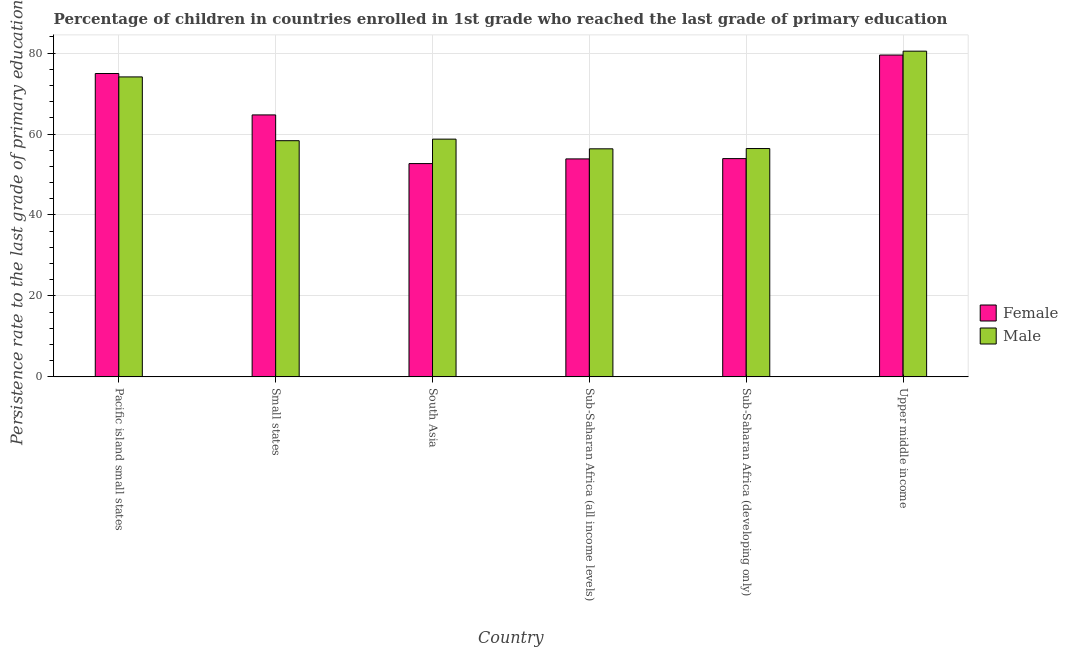What is the label of the 4th group of bars from the left?
Make the answer very short. Sub-Saharan Africa (all income levels). In how many cases, is the number of bars for a given country not equal to the number of legend labels?
Your answer should be very brief. 0. What is the persistence rate of male students in Sub-Saharan Africa (developing only)?
Offer a terse response. 56.41. Across all countries, what is the maximum persistence rate of male students?
Your response must be concise. 80.47. Across all countries, what is the minimum persistence rate of female students?
Offer a very short reply. 52.7. In which country was the persistence rate of female students maximum?
Your response must be concise. Upper middle income. In which country was the persistence rate of female students minimum?
Provide a succinct answer. South Asia. What is the total persistence rate of male students in the graph?
Offer a terse response. 384.43. What is the difference between the persistence rate of female students in Small states and that in Sub-Saharan Africa (all income levels)?
Offer a very short reply. 10.87. What is the difference between the persistence rate of female students in Sub-Saharan Africa (all income levels) and the persistence rate of male students in Pacific island small states?
Keep it short and to the point. -20.26. What is the average persistence rate of male students per country?
Offer a very short reply. 64.07. What is the difference between the persistence rate of female students and persistence rate of male students in Upper middle income?
Give a very brief answer. -0.96. What is the ratio of the persistence rate of male students in South Asia to that in Upper middle income?
Provide a short and direct response. 0.73. Is the persistence rate of male students in Small states less than that in South Asia?
Make the answer very short. Yes. Is the difference between the persistence rate of female students in Small states and South Asia greater than the difference between the persistence rate of male students in Small states and South Asia?
Make the answer very short. Yes. What is the difference between the highest and the second highest persistence rate of female students?
Make the answer very short. 4.57. What is the difference between the highest and the lowest persistence rate of female students?
Your response must be concise. 26.82. What does the 2nd bar from the left in South Asia represents?
Provide a short and direct response. Male. How many countries are there in the graph?
Offer a very short reply. 6. Does the graph contain any zero values?
Your answer should be very brief. No. Does the graph contain grids?
Your response must be concise. Yes. Where does the legend appear in the graph?
Your response must be concise. Center right. What is the title of the graph?
Ensure brevity in your answer.  Percentage of children in countries enrolled in 1st grade who reached the last grade of primary education. Does "IMF nonconcessional" appear as one of the legend labels in the graph?
Provide a succinct answer. No. What is the label or title of the X-axis?
Offer a very short reply. Country. What is the label or title of the Y-axis?
Give a very brief answer. Persistence rate to the last grade of primary education (%). What is the Persistence rate to the last grade of primary education (%) in Female in Pacific island small states?
Provide a succinct answer. 74.95. What is the Persistence rate to the last grade of primary education (%) in Male in Pacific island small states?
Provide a short and direct response. 74.11. What is the Persistence rate to the last grade of primary education (%) of Female in Small states?
Make the answer very short. 64.72. What is the Persistence rate to the last grade of primary education (%) in Male in Small states?
Make the answer very short. 58.35. What is the Persistence rate to the last grade of primary education (%) in Female in South Asia?
Provide a succinct answer. 52.7. What is the Persistence rate to the last grade of primary education (%) of Male in South Asia?
Provide a succinct answer. 58.74. What is the Persistence rate to the last grade of primary education (%) of Female in Sub-Saharan Africa (all income levels)?
Your response must be concise. 53.85. What is the Persistence rate to the last grade of primary education (%) of Male in Sub-Saharan Africa (all income levels)?
Provide a short and direct response. 56.34. What is the Persistence rate to the last grade of primary education (%) in Female in Sub-Saharan Africa (developing only)?
Give a very brief answer. 53.93. What is the Persistence rate to the last grade of primary education (%) in Male in Sub-Saharan Africa (developing only)?
Provide a short and direct response. 56.41. What is the Persistence rate to the last grade of primary education (%) of Female in Upper middle income?
Offer a terse response. 79.52. What is the Persistence rate to the last grade of primary education (%) in Male in Upper middle income?
Your answer should be compact. 80.47. Across all countries, what is the maximum Persistence rate to the last grade of primary education (%) of Female?
Provide a short and direct response. 79.52. Across all countries, what is the maximum Persistence rate to the last grade of primary education (%) of Male?
Your response must be concise. 80.47. Across all countries, what is the minimum Persistence rate to the last grade of primary education (%) of Female?
Make the answer very short. 52.7. Across all countries, what is the minimum Persistence rate to the last grade of primary education (%) in Male?
Your answer should be very brief. 56.34. What is the total Persistence rate to the last grade of primary education (%) of Female in the graph?
Keep it short and to the point. 379.67. What is the total Persistence rate to the last grade of primary education (%) of Male in the graph?
Your answer should be compact. 384.43. What is the difference between the Persistence rate to the last grade of primary education (%) of Female in Pacific island small states and that in Small states?
Provide a short and direct response. 10.23. What is the difference between the Persistence rate to the last grade of primary education (%) of Male in Pacific island small states and that in Small states?
Provide a short and direct response. 15.76. What is the difference between the Persistence rate to the last grade of primary education (%) in Female in Pacific island small states and that in South Asia?
Keep it short and to the point. 22.25. What is the difference between the Persistence rate to the last grade of primary education (%) in Male in Pacific island small states and that in South Asia?
Keep it short and to the point. 15.37. What is the difference between the Persistence rate to the last grade of primary education (%) of Female in Pacific island small states and that in Sub-Saharan Africa (all income levels)?
Provide a succinct answer. 21.09. What is the difference between the Persistence rate to the last grade of primary education (%) of Male in Pacific island small states and that in Sub-Saharan Africa (all income levels)?
Offer a terse response. 17.77. What is the difference between the Persistence rate to the last grade of primary education (%) of Female in Pacific island small states and that in Sub-Saharan Africa (developing only)?
Offer a very short reply. 21.02. What is the difference between the Persistence rate to the last grade of primary education (%) of Male in Pacific island small states and that in Sub-Saharan Africa (developing only)?
Keep it short and to the point. 17.7. What is the difference between the Persistence rate to the last grade of primary education (%) in Female in Pacific island small states and that in Upper middle income?
Your answer should be very brief. -4.57. What is the difference between the Persistence rate to the last grade of primary education (%) of Male in Pacific island small states and that in Upper middle income?
Make the answer very short. -6.36. What is the difference between the Persistence rate to the last grade of primary education (%) in Female in Small states and that in South Asia?
Your answer should be very brief. 12.02. What is the difference between the Persistence rate to the last grade of primary education (%) in Male in Small states and that in South Asia?
Give a very brief answer. -0.38. What is the difference between the Persistence rate to the last grade of primary education (%) of Female in Small states and that in Sub-Saharan Africa (all income levels)?
Provide a succinct answer. 10.87. What is the difference between the Persistence rate to the last grade of primary education (%) of Male in Small states and that in Sub-Saharan Africa (all income levels)?
Keep it short and to the point. 2.01. What is the difference between the Persistence rate to the last grade of primary education (%) of Female in Small states and that in Sub-Saharan Africa (developing only)?
Your answer should be very brief. 10.79. What is the difference between the Persistence rate to the last grade of primary education (%) of Male in Small states and that in Sub-Saharan Africa (developing only)?
Give a very brief answer. 1.94. What is the difference between the Persistence rate to the last grade of primary education (%) in Female in Small states and that in Upper middle income?
Keep it short and to the point. -14.79. What is the difference between the Persistence rate to the last grade of primary education (%) of Male in Small states and that in Upper middle income?
Provide a succinct answer. -22.12. What is the difference between the Persistence rate to the last grade of primary education (%) of Female in South Asia and that in Sub-Saharan Africa (all income levels)?
Offer a terse response. -1.16. What is the difference between the Persistence rate to the last grade of primary education (%) of Male in South Asia and that in Sub-Saharan Africa (all income levels)?
Ensure brevity in your answer.  2.39. What is the difference between the Persistence rate to the last grade of primary education (%) in Female in South Asia and that in Sub-Saharan Africa (developing only)?
Offer a terse response. -1.23. What is the difference between the Persistence rate to the last grade of primary education (%) of Male in South Asia and that in Sub-Saharan Africa (developing only)?
Ensure brevity in your answer.  2.32. What is the difference between the Persistence rate to the last grade of primary education (%) in Female in South Asia and that in Upper middle income?
Give a very brief answer. -26.82. What is the difference between the Persistence rate to the last grade of primary education (%) of Male in South Asia and that in Upper middle income?
Your answer should be compact. -21.74. What is the difference between the Persistence rate to the last grade of primary education (%) in Female in Sub-Saharan Africa (all income levels) and that in Sub-Saharan Africa (developing only)?
Provide a succinct answer. -0.08. What is the difference between the Persistence rate to the last grade of primary education (%) in Male in Sub-Saharan Africa (all income levels) and that in Sub-Saharan Africa (developing only)?
Your answer should be compact. -0.07. What is the difference between the Persistence rate to the last grade of primary education (%) in Female in Sub-Saharan Africa (all income levels) and that in Upper middle income?
Offer a very short reply. -25.66. What is the difference between the Persistence rate to the last grade of primary education (%) of Male in Sub-Saharan Africa (all income levels) and that in Upper middle income?
Make the answer very short. -24.13. What is the difference between the Persistence rate to the last grade of primary education (%) in Female in Sub-Saharan Africa (developing only) and that in Upper middle income?
Provide a succinct answer. -25.59. What is the difference between the Persistence rate to the last grade of primary education (%) of Male in Sub-Saharan Africa (developing only) and that in Upper middle income?
Your answer should be very brief. -24.06. What is the difference between the Persistence rate to the last grade of primary education (%) of Female in Pacific island small states and the Persistence rate to the last grade of primary education (%) of Male in Small states?
Provide a short and direct response. 16.59. What is the difference between the Persistence rate to the last grade of primary education (%) in Female in Pacific island small states and the Persistence rate to the last grade of primary education (%) in Male in South Asia?
Give a very brief answer. 16.21. What is the difference between the Persistence rate to the last grade of primary education (%) of Female in Pacific island small states and the Persistence rate to the last grade of primary education (%) of Male in Sub-Saharan Africa (all income levels)?
Offer a very short reply. 18.6. What is the difference between the Persistence rate to the last grade of primary education (%) in Female in Pacific island small states and the Persistence rate to the last grade of primary education (%) in Male in Sub-Saharan Africa (developing only)?
Your response must be concise. 18.53. What is the difference between the Persistence rate to the last grade of primary education (%) of Female in Pacific island small states and the Persistence rate to the last grade of primary education (%) of Male in Upper middle income?
Your answer should be compact. -5.53. What is the difference between the Persistence rate to the last grade of primary education (%) of Female in Small states and the Persistence rate to the last grade of primary education (%) of Male in South Asia?
Give a very brief answer. 5.99. What is the difference between the Persistence rate to the last grade of primary education (%) in Female in Small states and the Persistence rate to the last grade of primary education (%) in Male in Sub-Saharan Africa (all income levels)?
Provide a short and direct response. 8.38. What is the difference between the Persistence rate to the last grade of primary education (%) of Female in Small states and the Persistence rate to the last grade of primary education (%) of Male in Sub-Saharan Africa (developing only)?
Make the answer very short. 8.31. What is the difference between the Persistence rate to the last grade of primary education (%) in Female in Small states and the Persistence rate to the last grade of primary education (%) in Male in Upper middle income?
Make the answer very short. -15.75. What is the difference between the Persistence rate to the last grade of primary education (%) of Female in South Asia and the Persistence rate to the last grade of primary education (%) of Male in Sub-Saharan Africa (all income levels)?
Offer a terse response. -3.65. What is the difference between the Persistence rate to the last grade of primary education (%) of Female in South Asia and the Persistence rate to the last grade of primary education (%) of Male in Sub-Saharan Africa (developing only)?
Keep it short and to the point. -3.72. What is the difference between the Persistence rate to the last grade of primary education (%) of Female in South Asia and the Persistence rate to the last grade of primary education (%) of Male in Upper middle income?
Ensure brevity in your answer.  -27.78. What is the difference between the Persistence rate to the last grade of primary education (%) in Female in Sub-Saharan Africa (all income levels) and the Persistence rate to the last grade of primary education (%) in Male in Sub-Saharan Africa (developing only)?
Give a very brief answer. -2.56. What is the difference between the Persistence rate to the last grade of primary education (%) in Female in Sub-Saharan Africa (all income levels) and the Persistence rate to the last grade of primary education (%) in Male in Upper middle income?
Keep it short and to the point. -26.62. What is the difference between the Persistence rate to the last grade of primary education (%) of Female in Sub-Saharan Africa (developing only) and the Persistence rate to the last grade of primary education (%) of Male in Upper middle income?
Provide a short and direct response. -26.54. What is the average Persistence rate to the last grade of primary education (%) in Female per country?
Offer a terse response. 63.28. What is the average Persistence rate to the last grade of primary education (%) of Male per country?
Make the answer very short. 64.07. What is the difference between the Persistence rate to the last grade of primary education (%) of Female and Persistence rate to the last grade of primary education (%) of Male in Pacific island small states?
Offer a terse response. 0.84. What is the difference between the Persistence rate to the last grade of primary education (%) of Female and Persistence rate to the last grade of primary education (%) of Male in Small states?
Your answer should be compact. 6.37. What is the difference between the Persistence rate to the last grade of primary education (%) of Female and Persistence rate to the last grade of primary education (%) of Male in South Asia?
Your answer should be very brief. -6.04. What is the difference between the Persistence rate to the last grade of primary education (%) of Female and Persistence rate to the last grade of primary education (%) of Male in Sub-Saharan Africa (all income levels)?
Give a very brief answer. -2.49. What is the difference between the Persistence rate to the last grade of primary education (%) of Female and Persistence rate to the last grade of primary education (%) of Male in Sub-Saharan Africa (developing only)?
Give a very brief answer. -2.48. What is the difference between the Persistence rate to the last grade of primary education (%) of Female and Persistence rate to the last grade of primary education (%) of Male in Upper middle income?
Keep it short and to the point. -0.96. What is the ratio of the Persistence rate to the last grade of primary education (%) of Female in Pacific island small states to that in Small states?
Your answer should be compact. 1.16. What is the ratio of the Persistence rate to the last grade of primary education (%) of Male in Pacific island small states to that in Small states?
Make the answer very short. 1.27. What is the ratio of the Persistence rate to the last grade of primary education (%) in Female in Pacific island small states to that in South Asia?
Your response must be concise. 1.42. What is the ratio of the Persistence rate to the last grade of primary education (%) in Male in Pacific island small states to that in South Asia?
Make the answer very short. 1.26. What is the ratio of the Persistence rate to the last grade of primary education (%) of Female in Pacific island small states to that in Sub-Saharan Africa (all income levels)?
Offer a terse response. 1.39. What is the ratio of the Persistence rate to the last grade of primary education (%) of Male in Pacific island small states to that in Sub-Saharan Africa (all income levels)?
Your answer should be very brief. 1.32. What is the ratio of the Persistence rate to the last grade of primary education (%) of Female in Pacific island small states to that in Sub-Saharan Africa (developing only)?
Your answer should be very brief. 1.39. What is the ratio of the Persistence rate to the last grade of primary education (%) of Male in Pacific island small states to that in Sub-Saharan Africa (developing only)?
Offer a terse response. 1.31. What is the ratio of the Persistence rate to the last grade of primary education (%) in Female in Pacific island small states to that in Upper middle income?
Your response must be concise. 0.94. What is the ratio of the Persistence rate to the last grade of primary education (%) in Male in Pacific island small states to that in Upper middle income?
Give a very brief answer. 0.92. What is the ratio of the Persistence rate to the last grade of primary education (%) in Female in Small states to that in South Asia?
Provide a short and direct response. 1.23. What is the ratio of the Persistence rate to the last grade of primary education (%) of Male in Small states to that in South Asia?
Offer a terse response. 0.99. What is the ratio of the Persistence rate to the last grade of primary education (%) of Female in Small states to that in Sub-Saharan Africa (all income levels)?
Make the answer very short. 1.2. What is the ratio of the Persistence rate to the last grade of primary education (%) in Male in Small states to that in Sub-Saharan Africa (all income levels)?
Offer a very short reply. 1.04. What is the ratio of the Persistence rate to the last grade of primary education (%) in Female in Small states to that in Sub-Saharan Africa (developing only)?
Offer a terse response. 1.2. What is the ratio of the Persistence rate to the last grade of primary education (%) in Male in Small states to that in Sub-Saharan Africa (developing only)?
Offer a terse response. 1.03. What is the ratio of the Persistence rate to the last grade of primary education (%) in Female in Small states to that in Upper middle income?
Give a very brief answer. 0.81. What is the ratio of the Persistence rate to the last grade of primary education (%) of Male in Small states to that in Upper middle income?
Your answer should be very brief. 0.73. What is the ratio of the Persistence rate to the last grade of primary education (%) in Female in South Asia to that in Sub-Saharan Africa (all income levels)?
Offer a terse response. 0.98. What is the ratio of the Persistence rate to the last grade of primary education (%) in Male in South Asia to that in Sub-Saharan Africa (all income levels)?
Keep it short and to the point. 1.04. What is the ratio of the Persistence rate to the last grade of primary education (%) in Female in South Asia to that in Sub-Saharan Africa (developing only)?
Make the answer very short. 0.98. What is the ratio of the Persistence rate to the last grade of primary education (%) of Male in South Asia to that in Sub-Saharan Africa (developing only)?
Your answer should be very brief. 1.04. What is the ratio of the Persistence rate to the last grade of primary education (%) of Female in South Asia to that in Upper middle income?
Your answer should be very brief. 0.66. What is the ratio of the Persistence rate to the last grade of primary education (%) of Male in South Asia to that in Upper middle income?
Your response must be concise. 0.73. What is the ratio of the Persistence rate to the last grade of primary education (%) in Male in Sub-Saharan Africa (all income levels) to that in Sub-Saharan Africa (developing only)?
Your answer should be compact. 1. What is the ratio of the Persistence rate to the last grade of primary education (%) in Female in Sub-Saharan Africa (all income levels) to that in Upper middle income?
Give a very brief answer. 0.68. What is the ratio of the Persistence rate to the last grade of primary education (%) in Male in Sub-Saharan Africa (all income levels) to that in Upper middle income?
Your response must be concise. 0.7. What is the ratio of the Persistence rate to the last grade of primary education (%) in Female in Sub-Saharan Africa (developing only) to that in Upper middle income?
Provide a short and direct response. 0.68. What is the ratio of the Persistence rate to the last grade of primary education (%) of Male in Sub-Saharan Africa (developing only) to that in Upper middle income?
Keep it short and to the point. 0.7. What is the difference between the highest and the second highest Persistence rate to the last grade of primary education (%) of Female?
Provide a succinct answer. 4.57. What is the difference between the highest and the second highest Persistence rate to the last grade of primary education (%) in Male?
Ensure brevity in your answer.  6.36. What is the difference between the highest and the lowest Persistence rate to the last grade of primary education (%) of Female?
Offer a terse response. 26.82. What is the difference between the highest and the lowest Persistence rate to the last grade of primary education (%) of Male?
Make the answer very short. 24.13. 